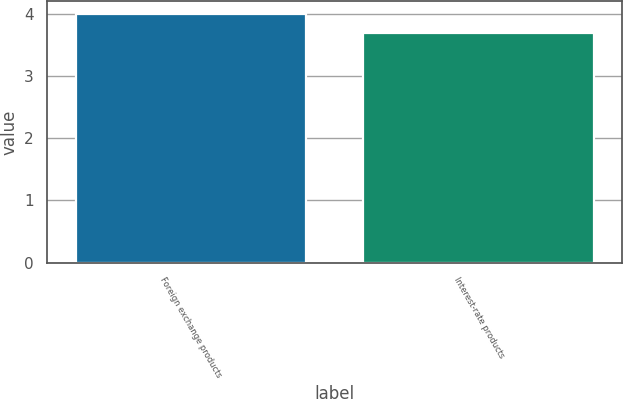Convert chart. <chart><loc_0><loc_0><loc_500><loc_500><bar_chart><fcel>Foreign exchange products<fcel>Interest-rate products<nl><fcel>4<fcel>3.7<nl></chart> 